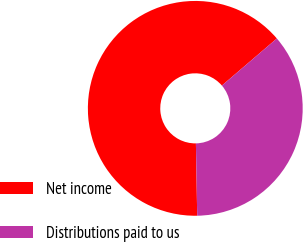<chart> <loc_0><loc_0><loc_500><loc_500><pie_chart><fcel>Net income<fcel>Distributions paid to us<nl><fcel>64.01%<fcel>35.99%<nl></chart> 